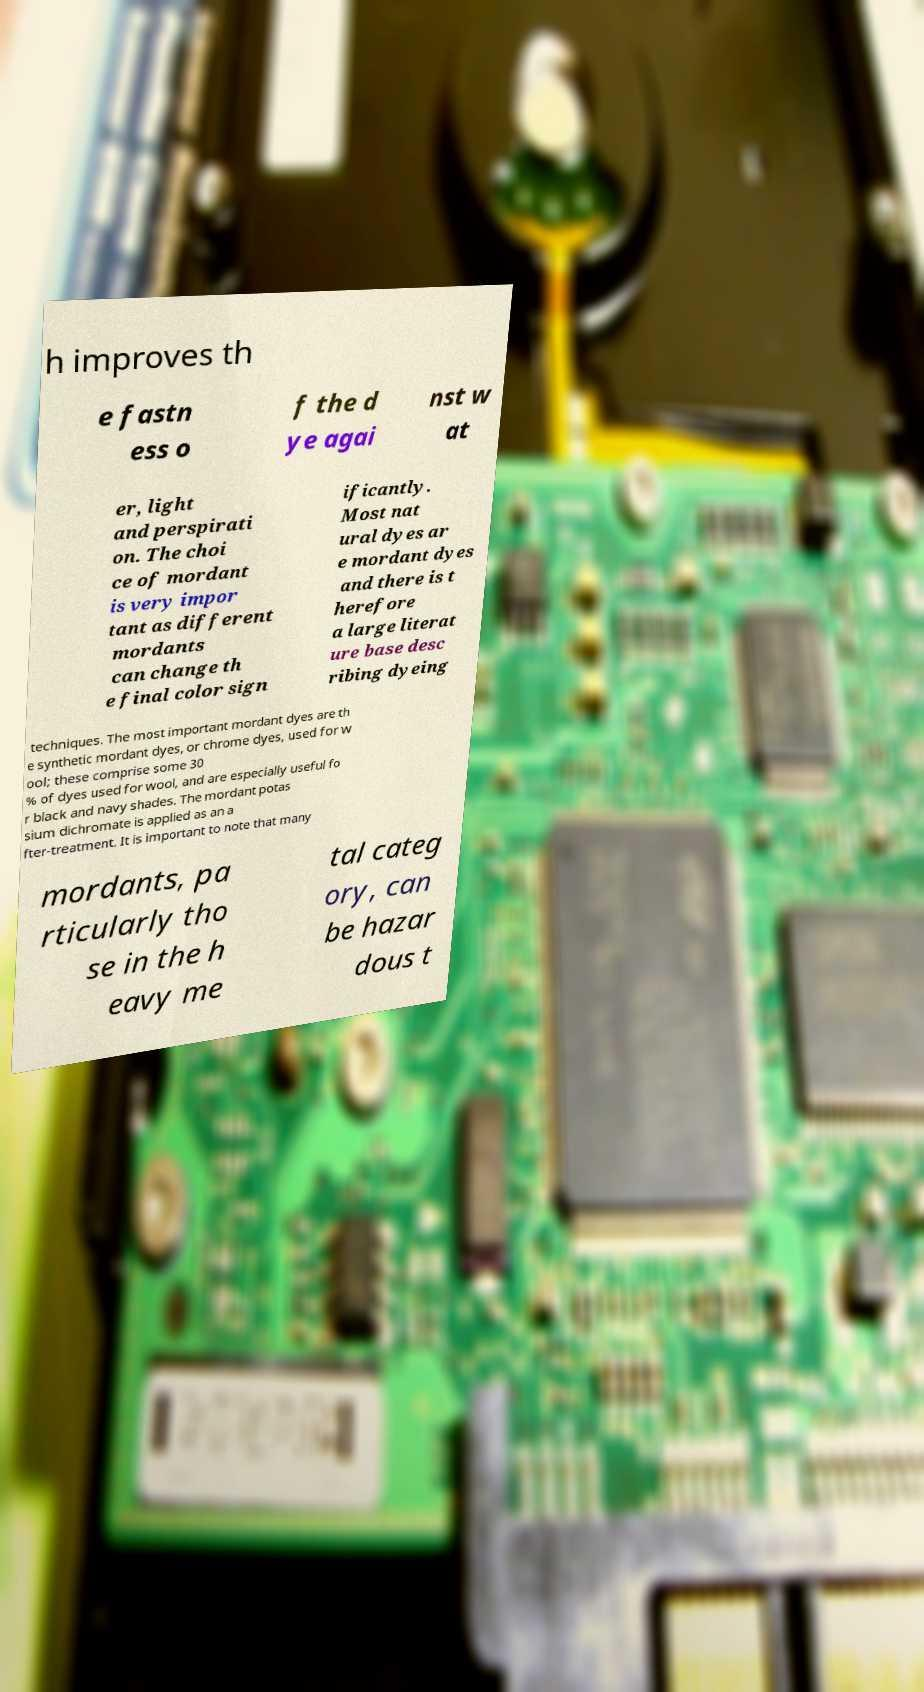Please identify and transcribe the text found in this image. h improves th e fastn ess o f the d ye agai nst w at er, light and perspirati on. The choi ce of mordant is very impor tant as different mordants can change th e final color sign ificantly. Most nat ural dyes ar e mordant dyes and there is t herefore a large literat ure base desc ribing dyeing techniques. The most important mordant dyes are th e synthetic mordant dyes, or chrome dyes, used for w ool; these comprise some 30 % of dyes used for wool, and are especially useful fo r black and navy shades. The mordant potas sium dichromate is applied as an a fter-treatment. It is important to note that many mordants, pa rticularly tho se in the h eavy me tal categ ory, can be hazar dous t 